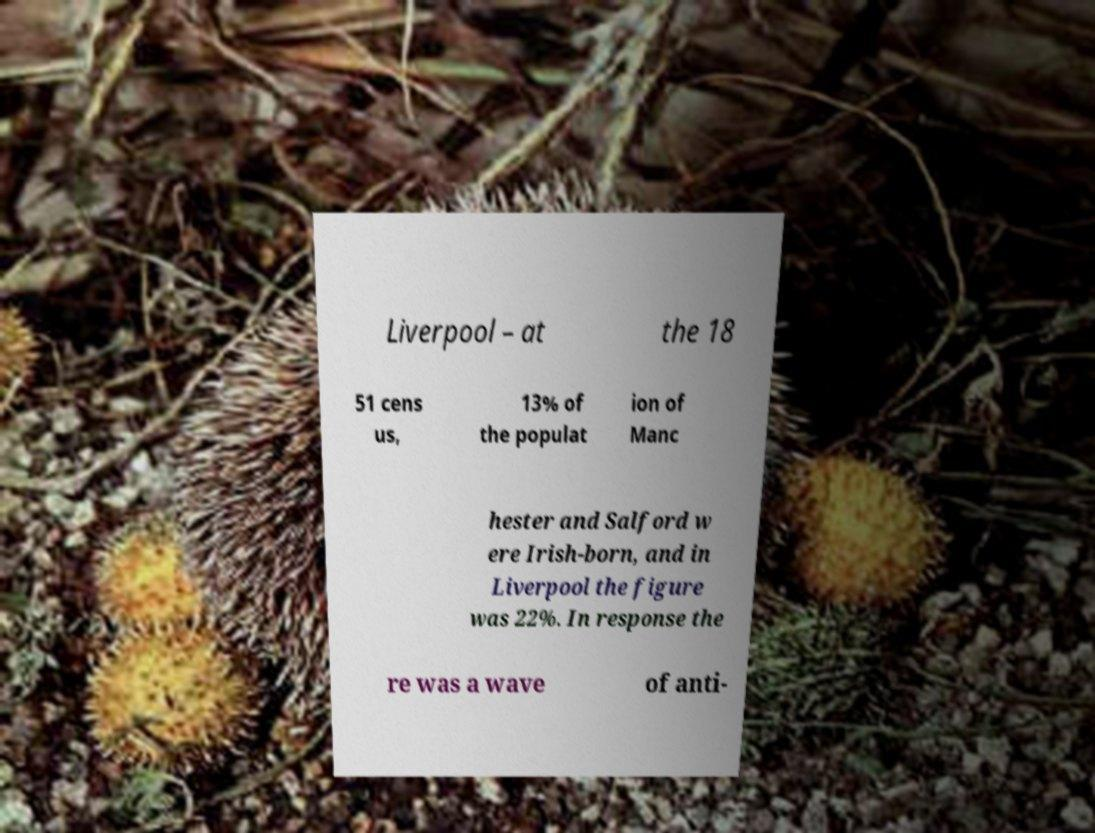Please identify and transcribe the text found in this image. Liverpool – at the 18 51 cens us, 13% of the populat ion of Manc hester and Salford w ere Irish-born, and in Liverpool the figure was 22%. In response the re was a wave of anti- 